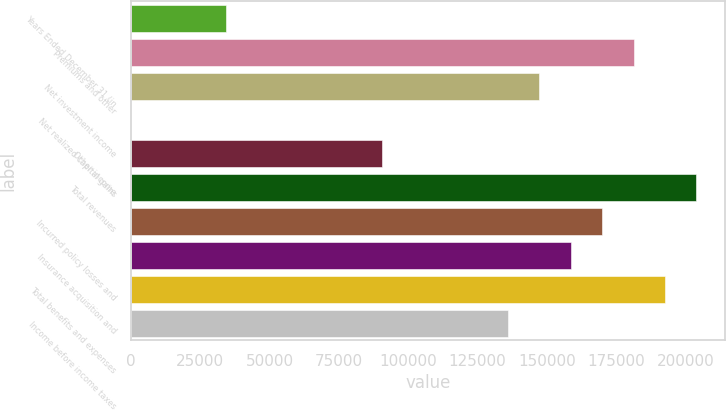Convert chart to OTSL. <chart><loc_0><loc_0><loc_500><loc_500><bar_chart><fcel>Years Ended December 31 (in<fcel>Premiums and other<fcel>Net investment income<fcel>Net realized capital gains<fcel>Other income<fcel>Total revenues<fcel>Incurred policy losses and<fcel>Insurance acquisition and<fcel>Total benefits and expenses<fcel>Income before income taxes<nl><fcel>34090.3<fcel>181356<fcel>147371<fcel>106<fcel>90730.8<fcel>204012<fcel>170028<fcel>158699<fcel>192684<fcel>136043<nl></chart> 